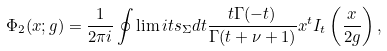Convert formula to latex. <formula><loc_0><loc_0><loc_500><loc_500>\Phi _ { 2 } ( x ; g ) = \frac { 1 } { 2 \pi i } \oint \lim i t s _ { \Sigma } d t \frac { t \Gamma ( - t ) } { \Gamma ( t + \nu + 1 ) } x ^ { t } I _ { t } \left ( \frac { x } { 2 g } \right ) ,</formula> 